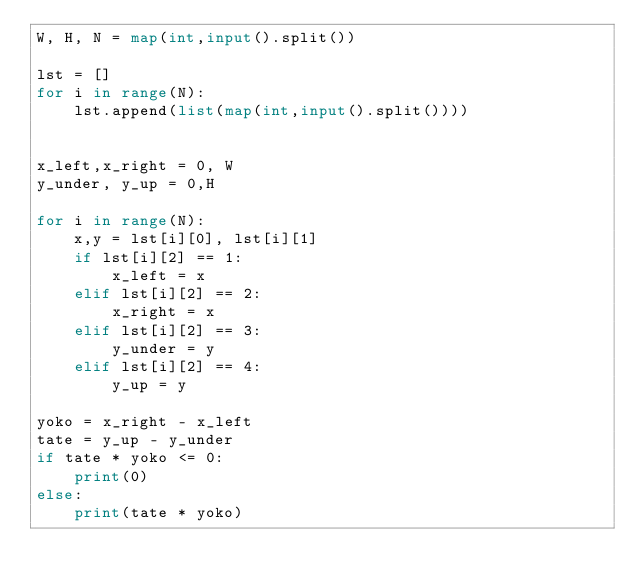Convert code to text. <code><loc_0><loc_0><loc_500><loc_500><_Python_>W, H, N = map(int,input().split())

lst = []
for i in range(N):
    lst.append(list(map(int,input().split())))


x_left,x_right = 0, W
y_under, y_up = 0,H

for i in range(N):
    x,y = lst[i][0], lst[i][1]
    if lst[i][2] == 1:
        x_left = x
    elif lst[i][2] == 2:
        x_right = x
    elif lst[i][2] == 3:
        y_under = y
    elif lst[i][2] == 4:
        y_up = y

yoko = x_right - x_left
tate = y_up - y_under
if tate * yoko <= 0:
    print(0)
else:
    print(tate * yoko)
</code> 